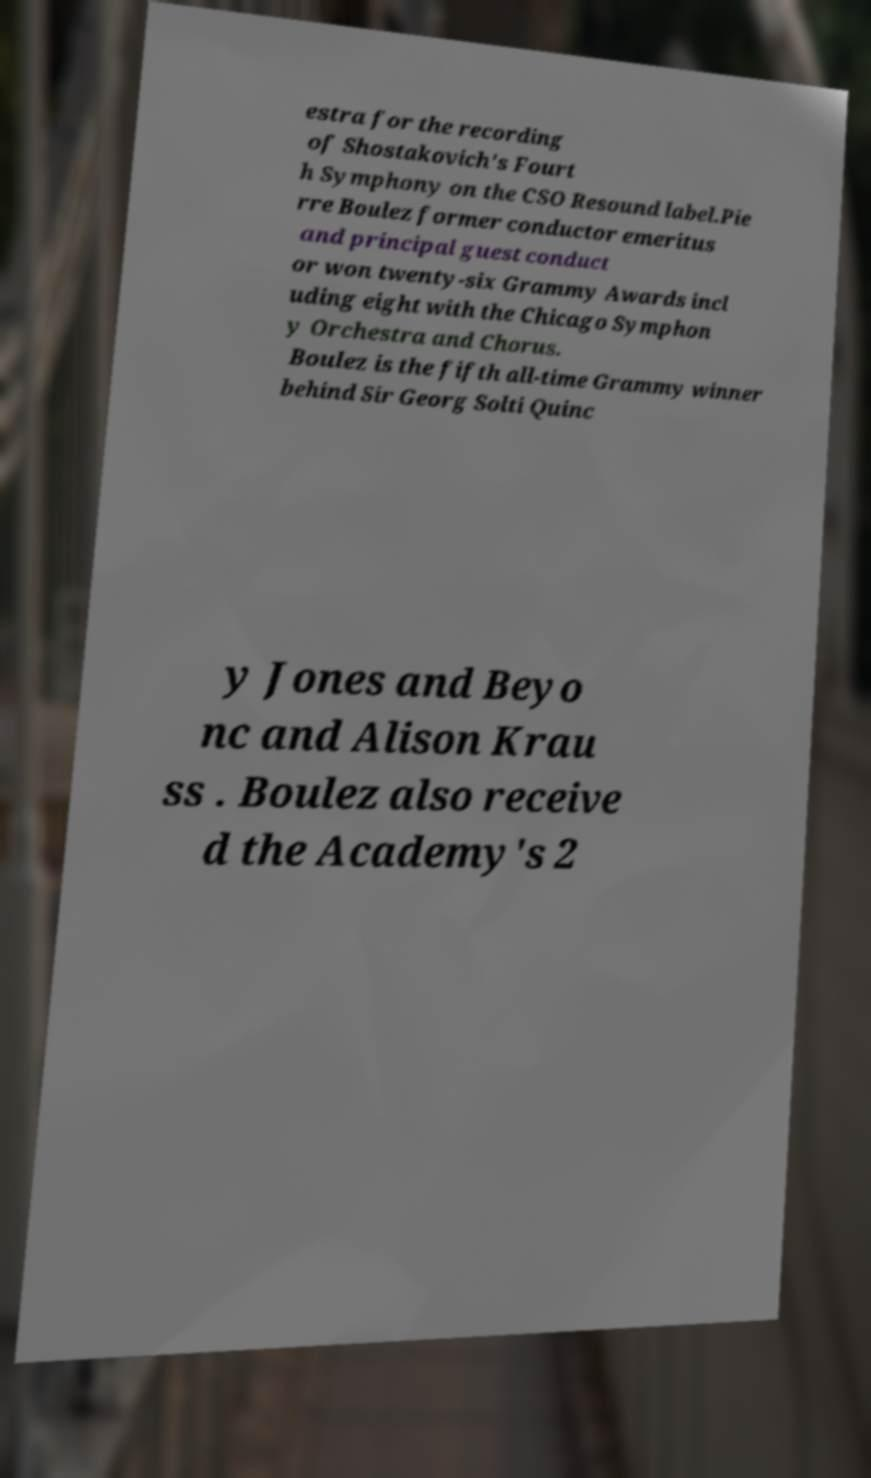Could you assist in decoding the text presented in this image and type it out clearly? estra for the recording of Shostakovich's Fourt h Symphony on the CSO Resound label.Pie rre Boulez former conductor emeritus and principal guest conduct or won twenty-six Grammy Awards incl uding eight with the Chicago Symphon y Orchestra and Chorus. Boulez is the fifth all-time Grammy winner behind Sir Georg Solti Quinc y Jones and Beyo nc and Alison Krau ss . Boulez also receive d the Academy's 2 